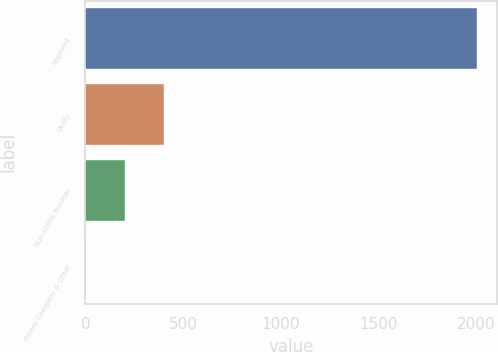Convert chart. <chart><loc_0><loc_0><loc_500><loc_500><bar_chart><fcel>Segment<fcel>Utility<fcel>Non-Utility Nuclear<fcel>Parent Company & Other<nl><fcel>2008<fcel>403.2<fcel>202.6<fcel>2<nl></chart> 